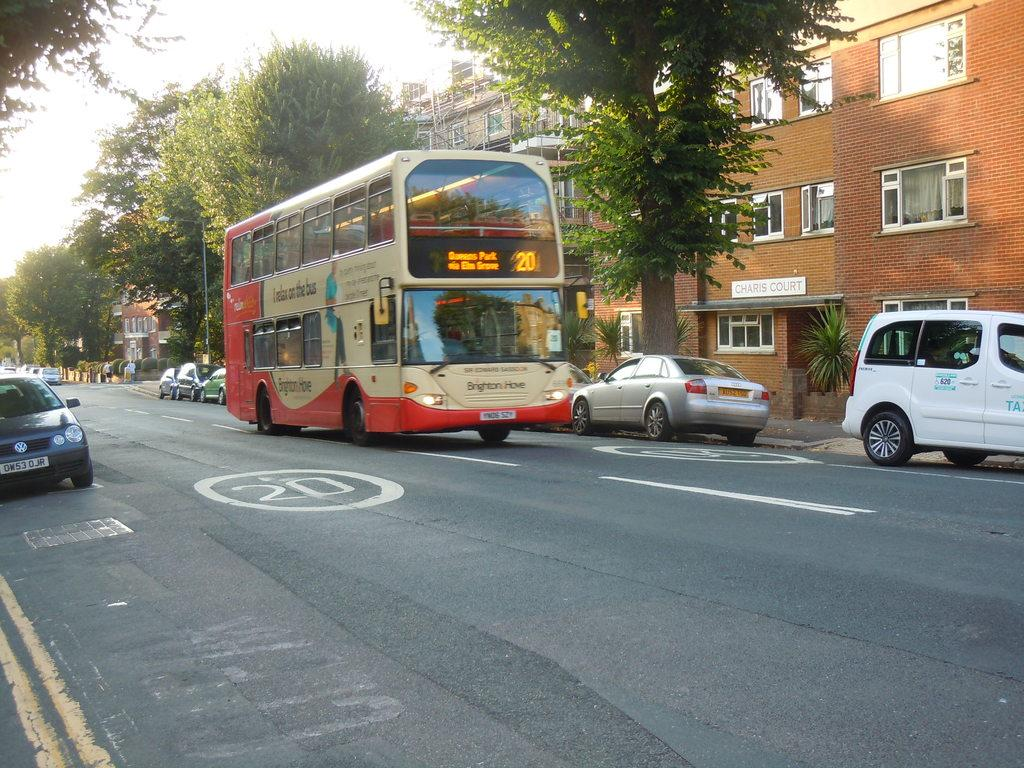What type of vehicle is in the image? There is a red color bus in the image. What is the bus doing in the image? The bus is moving on the road. What else can be seen on the road in the image? There are parked cars on the roadside. What can be seen in the background of the image? There is a brown color building and trees visible in the background. What type of cork is being used by the fireman in the image? There is no fireman or cork present in the image. How many quivers can be seen on the trees in the image? There are no quivers visible in the image; only trees are present in the background. 